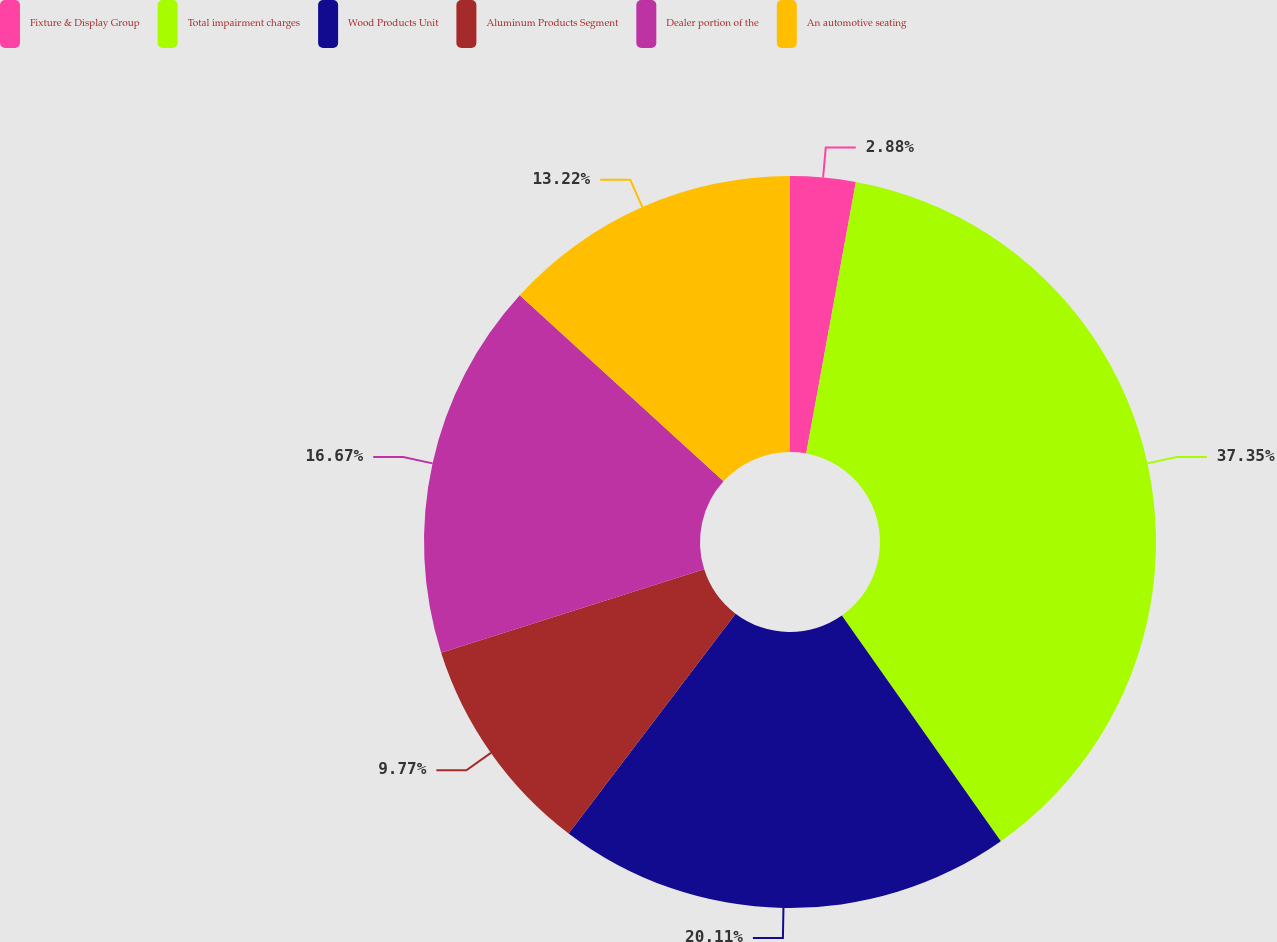Convert chart. <chart><loc_0><loc_0><loc_500><loc_500><pie_chart><fcel>Fixture & Display Group<fcel>Total impairment charges<fcel>Wood Products Unit<fcel>Aluminum Products Segment<fcel>Dealer portion of the<fcel>An automotive seating<nl><fcel>2.88%<fcel>37.35%<fcel>20.11%<fcel>9.77%<fcel>16.67%<fcel>13.22%<nl></chart> 